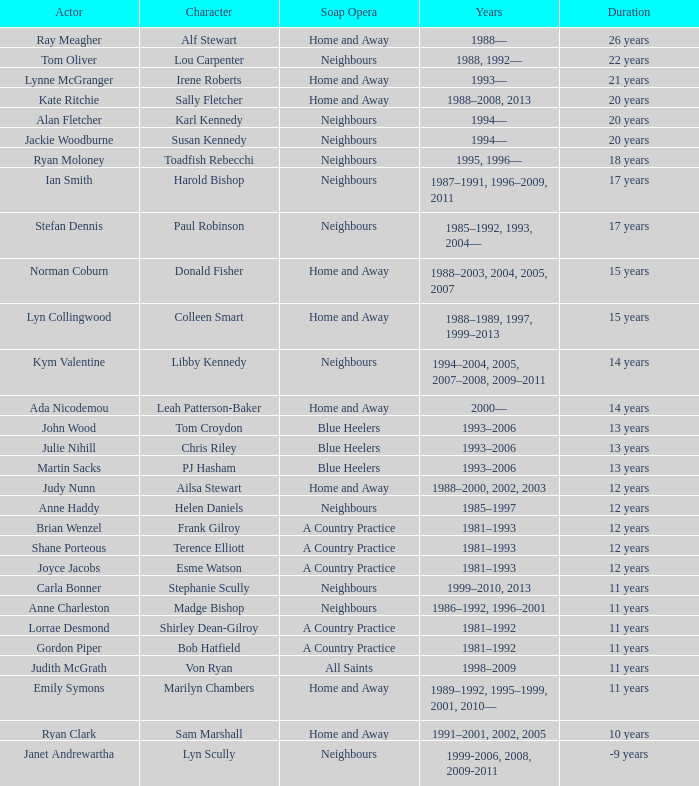Which actor played on Home and Away for 20 years? Kate Ritchie. 